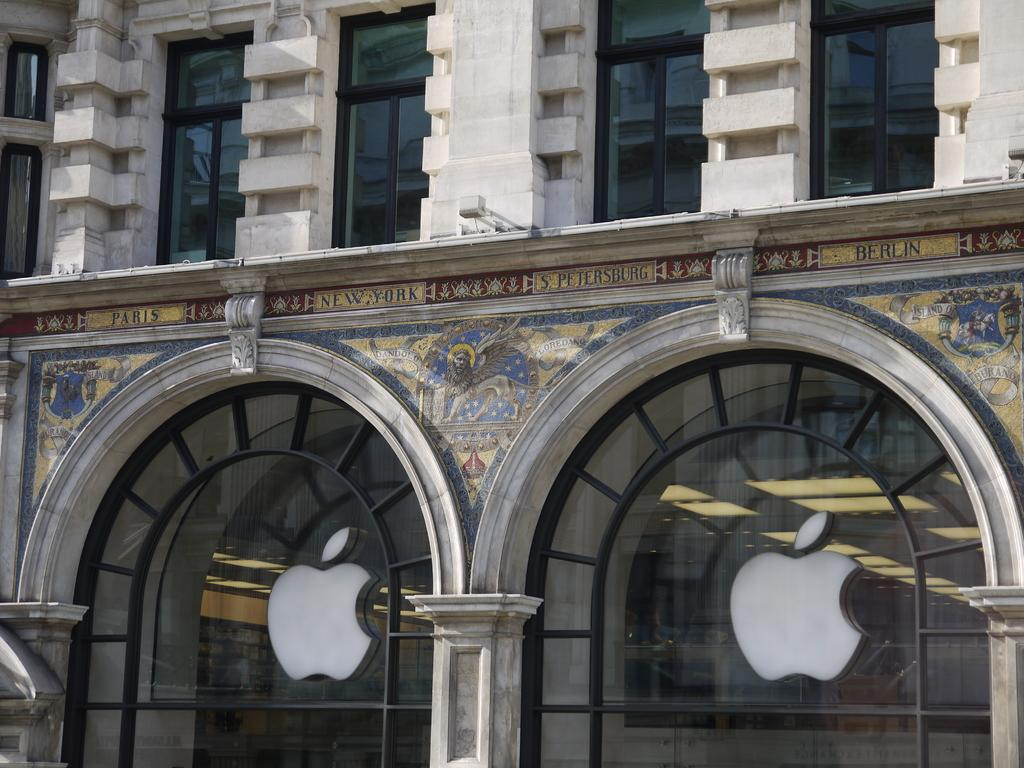What type of structure can be seen in the image? There is a wall in the image. What feature is present on the wall? The wall has glass windows. What architectural element is visible in the image? There are arches in the image. What company is represented in the image? There are Apple logos in the image. What is written on the wall? There is text on the wall. What type of decoration is present on the wall? There is art on the wall. Is there a calendar hanging on the wall in the image? There is no mention of a calendar in the provided facts, so we cannot determine if one is present in the image. 